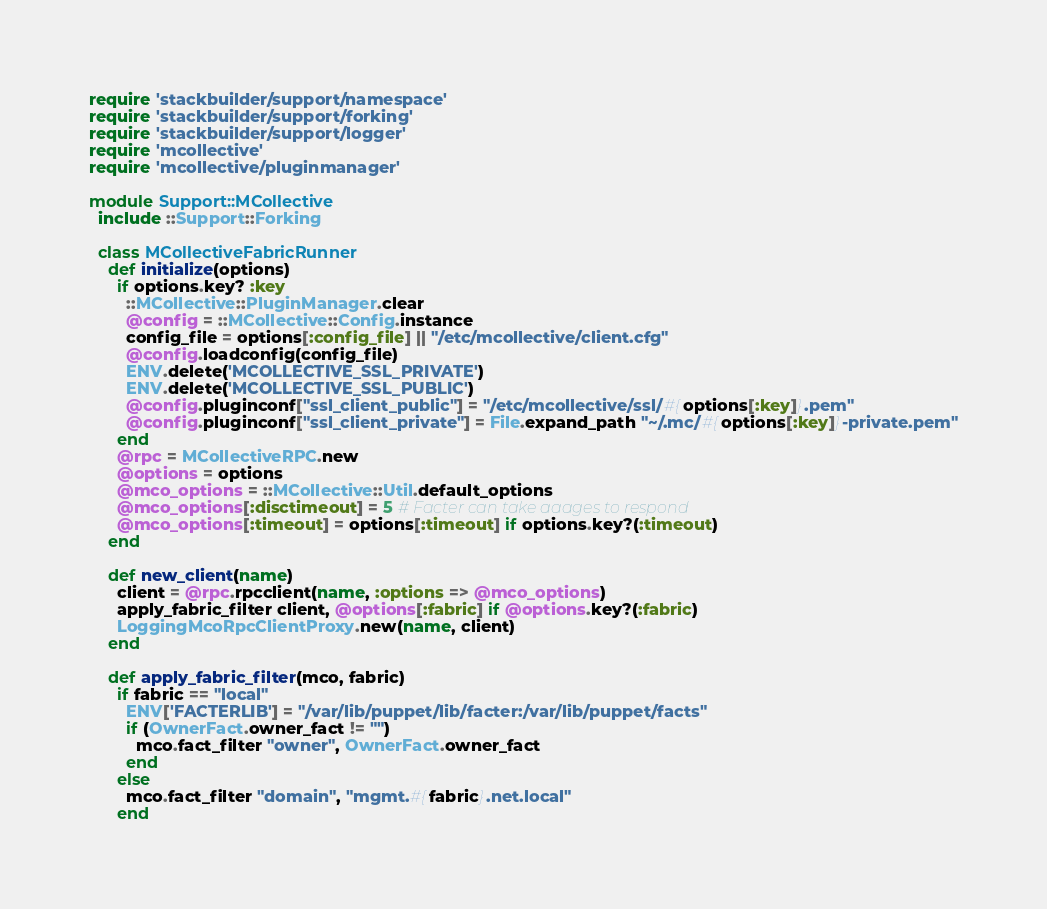Convert code to text. <code><loc_0><loc_0><loc_500><loc_500><_Ruby_>require 'stackbuilder/support/namespace'
require 'stackbuilder/support/forking'
require 'stackbuilder/support/logger'
require 'mcollective'
require 'mcollective/pluginmanager'

module Support::MCollective
  include ::Support::Forking

  class MCollectiveFabricRunner
    def initialize(options)
      if options.key? :key
        ::MCollective::PluginManager.clear
        @config = ::MCollective::Config.instance
        config_file = options[:config_file] || "/etc/mcollective/client.cfg"
        @config.loadconfig(config_file)
        ENV.delete('MCOLLECTIVE_SSL_PRIVATE')
        ENV.delete('MCOLLECTIVE_SSL_PUBLIC')
        @config.pluginconf["ssl_client_public"] = "/etc/mcollective/ssl/#{options[:key]}.pem"
        @config.pluginconf["ssl_client_private"] = File.expand_path "~/.mc/#{options[:key]}-private.pem"
      end
      @rpc = MCollectiveRPC.new
      @options = options
      @mco_options = ::MCollective::Util.default_options
      @mco_options[:disctimeout] = 5 # Facter can take aaages to respond
      @mco_options[:timeout] = options[:timeout] if options.key?(:timeout)
    end

    def new_client(name)
      client = @rpc.rpcclient(name, :options => @mco_options)
      apply_fabric_filter client, @options[:fabric] if @options.key?(:fabric)
      LoggingMcoRpcClientProxy.new(name, client)
    end

    def apply_fabric_filter(mco, fabric)
      if fabric == "local"
        ENV['FACTERLIB'] = "/var/lib/puppet/lib/facter:/var/lib/puppet/facts"
        if (OwnerFact.owner_fact != "")
          mco.fact_filter "owner", OwnerFact.owner_fact
        end
      else
        mco.fact_filter "domain", "mgmt.#{fabric}.net.local"
      end</code> 